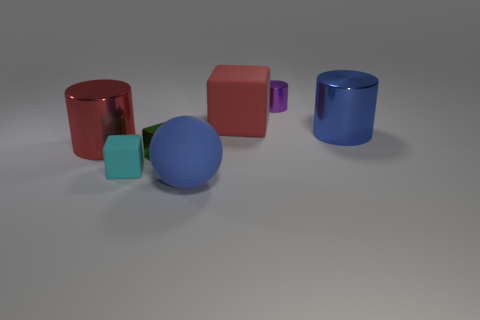Add 3 red rubber cubes. How many objects exist? 10 Subtract all spheres. How many objects are left? 6 Add 6 large green matte cubes. How many large green matte cubes exist? 6 Subtract 1 red cylinders. How many objects are left? 6 Subtract all red cylinders. Subtract all blue balls. How many objects are left? 5 Add 6 small matte cubes. How many small matte cubes are left? 7 